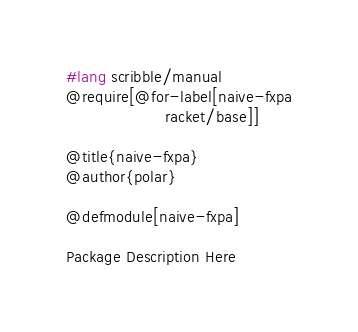<code> <loc_0><loc_0><loc_500><loc_500><_Racket_>#lang scribble/manual
@require[@for-label[naive-fxpa
                    racket/base]]

@title{naive-fxpa}
@author{polar}

@defmodule[naive-fxpa]

Package Description Here
</code> 